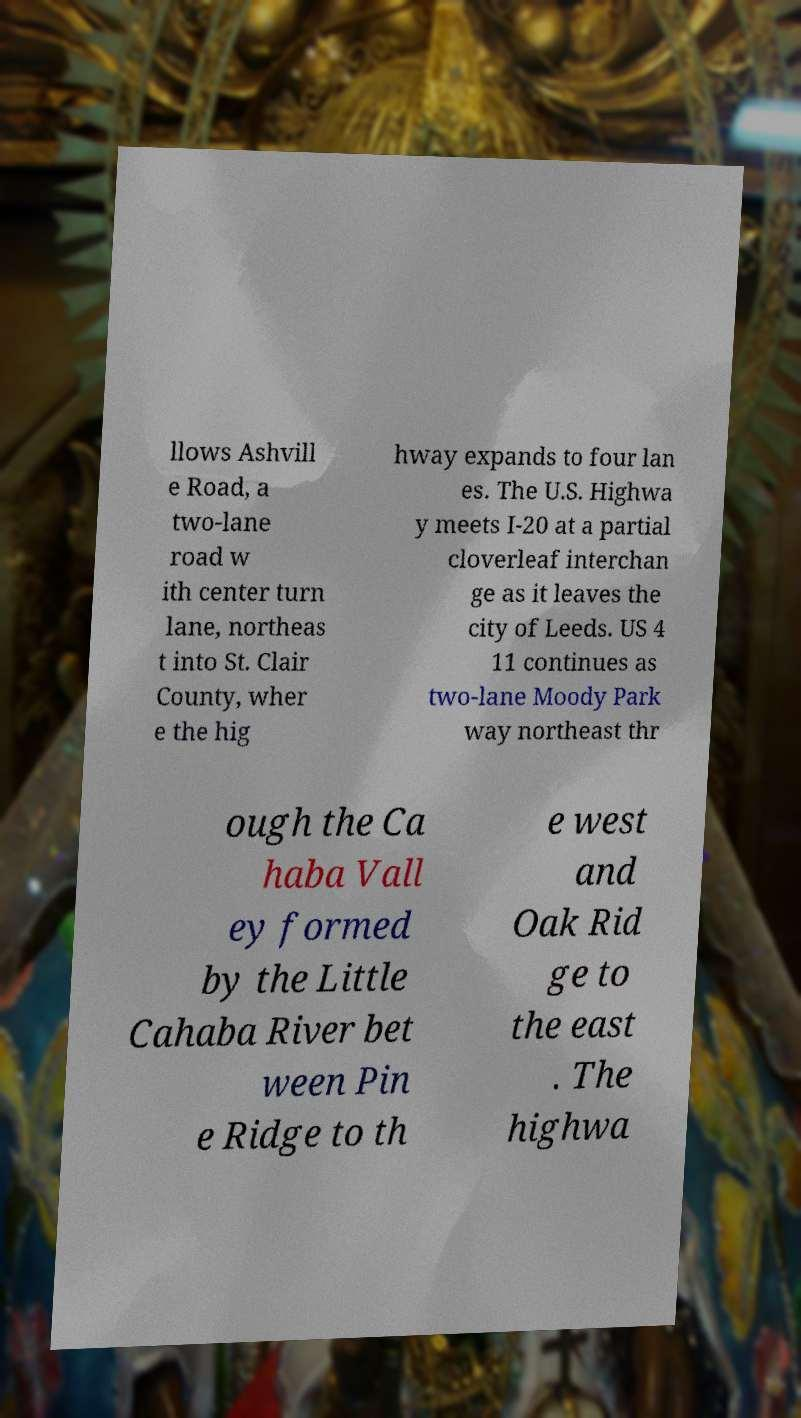Can you accurately transcribe the text from the provided image for me? llows Ashvill e Road, a two-lane road w ith center turn lane, northeas t into St. Clair County, wher e the hig hway expands to four lan es. The U.S. Highwa y meets I-20 at a partial cloverleaf interchan ge as it leaves the city of Leeds. US 4 11 continues as two-lane Moody Park way northeast thr ough the Ca haba Vall ey formed by the Little Cahaba River bet ween Pin e Ridge to th e west and Oak Rid ge to the east . The highwa 